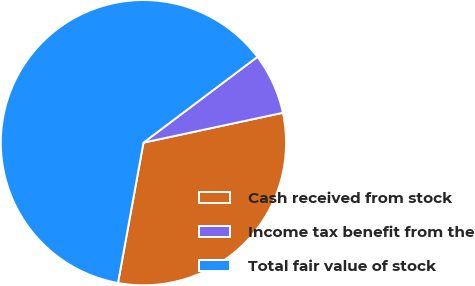Convert chart to OTSL. <chart><loc_0><loc_0><loc_500><loc_500><pie_chart><fcel>Cash received from stock<fcel>Income tax benefit from the<fcel>Total fair value of stock<nl><fcel>31.22%<fcel>6.91%<fcel>61.88%<nl></chart> 